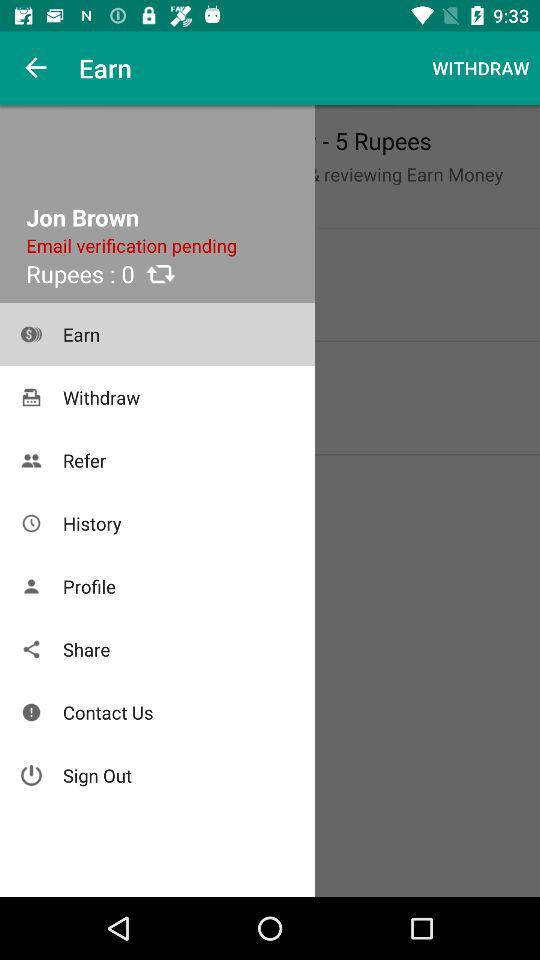What is the name of the user? The name of the user is Jon Brown. 